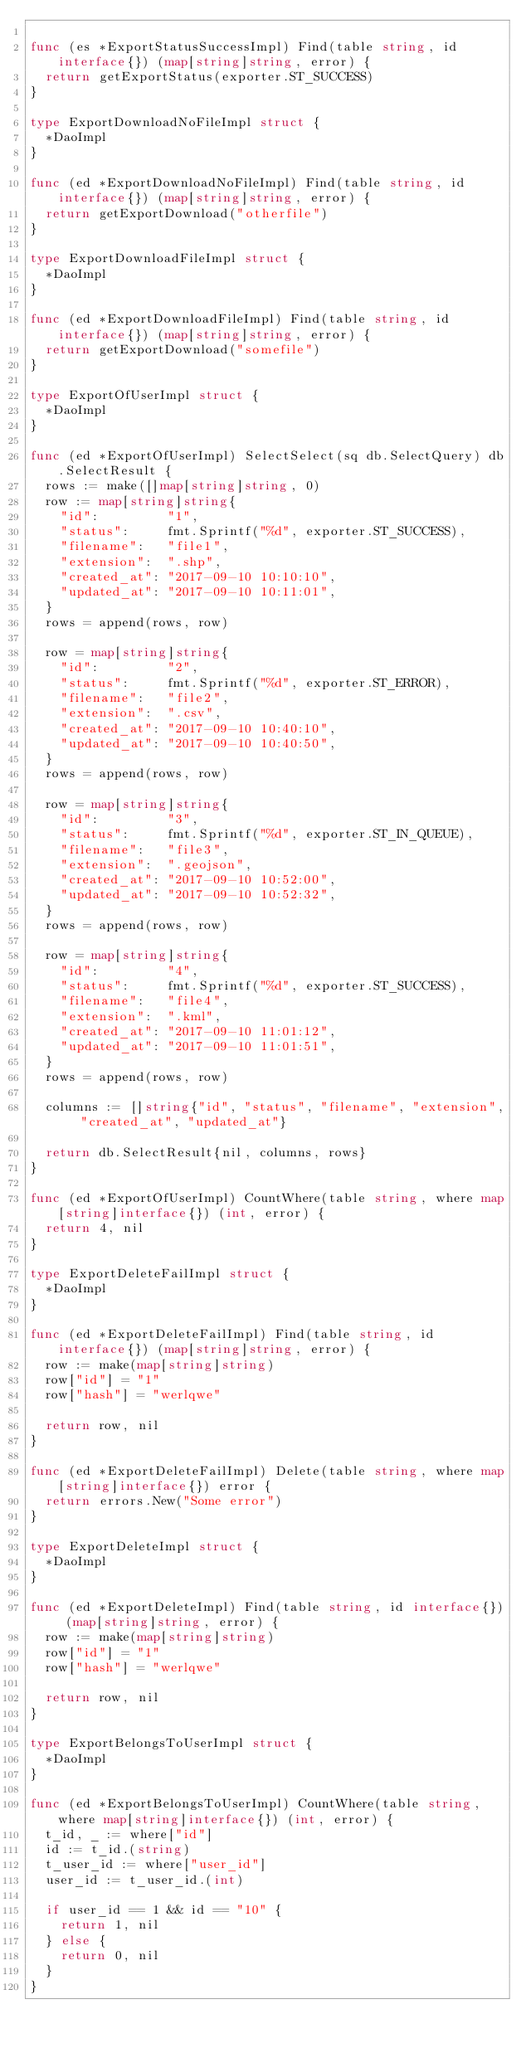Convert code to text. <code><loc_0><loc_0><loc_500><loc_500><_Go_>
func (es *ExportStatusSuccessImpl) Find(table string, id interface{}) (map[string]string, error) {
	return getExportStatus(exporter.ST_SUCCESS)
}

type ExportDownloadNoFileImpl struct {
	*DaoImpl
}

func (ed *ExportDownloadNoFileImpl) Find(table string, id interface{}) (map[string]string, error) {
	return getExportDownload("otherfile")
}

type ExportDownloadFileImpl struct {
	*DaoImpl
}

func (ed *ExportDownloadFileImpl) Find(table string, id interface{}) (map[string]string, error) {
	return getExportDownload("somefile")
}

type ExportOfUserImpl struct {
	*DaoImpl
}

func (ed *ExportOfUserImpl) SelectSelect(sq db.SelectQuery) db.SelectResult {
	rows := make([]map[string]string, 0)
	row := map[string]string{
		"id":         "1",
		"status":     fmt.Sprintf("%d", exporter.ST_SUCCESS),
		"filename":   "file1",
		"extension":  ".shp",
		"created_at": "2017-09-10 10:10:10",
		"updated_at": "2017-09-10 10:11:01",
	}
	rows = append(rows, row)

	row = map[string]string{
		"id":         "2",
		"status":     fmt.Sprintf("%d", exporter.ST_ERROR),
		"filename":   "file2",
		"extension":  ".csv",
		"created_at": "2017-09-10 10:40:10",
		"updated_at": "2017-09-10 10:40:50",
	}
	rows = append(rows, row)

	row = map[string]string{
		"id":         "3",
		"status":     fmt.Sprintf("%d", exporter.ST_IN_QUEUE),
		"filename":   "file3",
		"extension":  ".geojson",
		"created_at": "2017-09-10 10:52:00",
		"updated_at": "2017-09-10 10:52:32",
	}
	rows = append(rows, row)

	row = map[string]string{
		"id":         "4",
		"status":     fmt.Sprintf("%d", exporter.ST_SUCCESS),
		"filename":   "file4",
		"extension":  ".kml",
		"created_at": "2017-09-10 11:01:12",
		"updated_at": "2017-09-10 11:01:51",
	}
	rows = append(rows, row)

	columns := []string{"id", "status", "filename", "extension", "created_at", "updated_at"}

	return db.SelectResult{nil, columns, rows}
}

func (ed *ExportOfUserImpl) CountWhere(table string, where map[string]interface{}) (int, error) {
	return 4, nil
}

type ExportDeleteFailImpl struct {
	*DaoImpl
}

func (ed *ExportDeleteFailImpl) Find(table string, id interface{}) (map[string]string, error) {
	row := make(map[string]string)
	row["id"] = "1"
	row["hash"] = "werlqwe"

	return row, nil
}

func (ed *ExportDeleteFailImpl) Delete(table string, where map[string]interface{}) error {
	return errors.New("Some error")
}

type ExportDeleteImpl struct {
	*DaoImpl
}

func (ed *ExportDeleteImpl) Find(table string, id interface{}) (map[string]string, error) {
	row := make(map[string]string)
	row["id"] = "1"
	row["hash"] = "werlqwe"

	return row, nil
}

type ExportBelongsToUserImpl struct {
	*DaoImpl
}

func (ed *ExportBelongsToUserImpl) CountWhere(table string, where map[string]interface{}) (int, error) {
	t_id, _ := where["id"]
	id := t_id.(string)
	t_user_id := where["user_id"]
	user_id := t_user_id.(int)

	if user_id == 1 && id == "10" {
		return 1, nil
	} else {
		return 0, nil
	}
}
</code> 